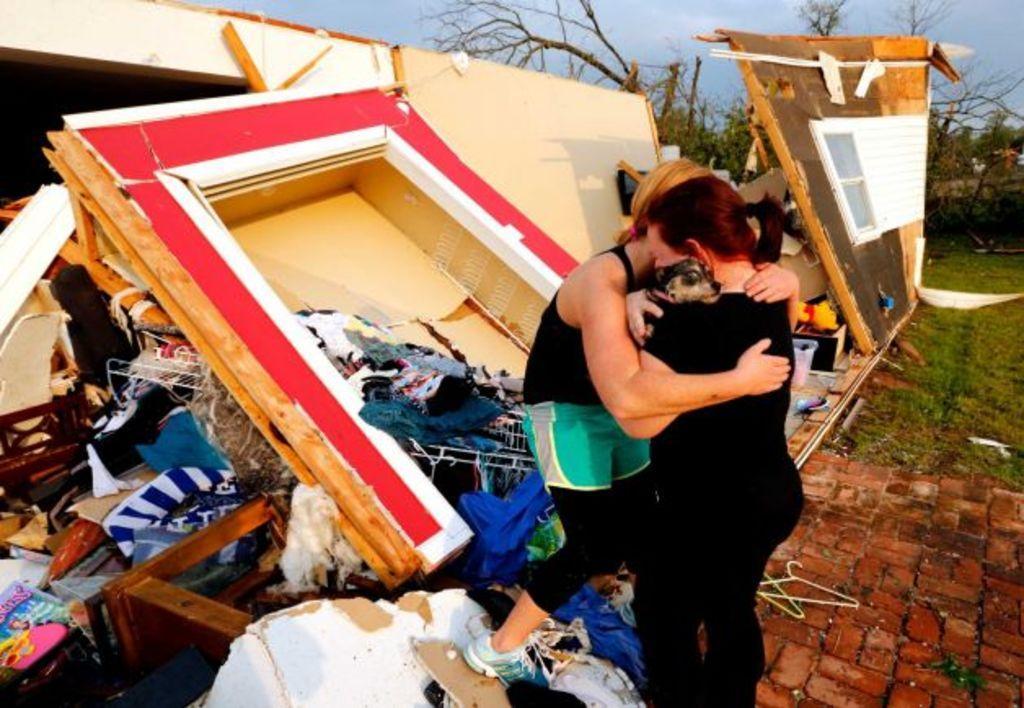Please provide a concise description of this image. In the middle of the image there is a lady with black dress is standing and holding the dog in her hand. In front of her there is another lady with black and green dress is standing and both are hugging each other. Behind there is house collapsed and also there are few items on the ground. To the right corner of the image to the bottom there is a brick path and above that there is a ground with grass. And in the background there are trees and also there is a sky. 